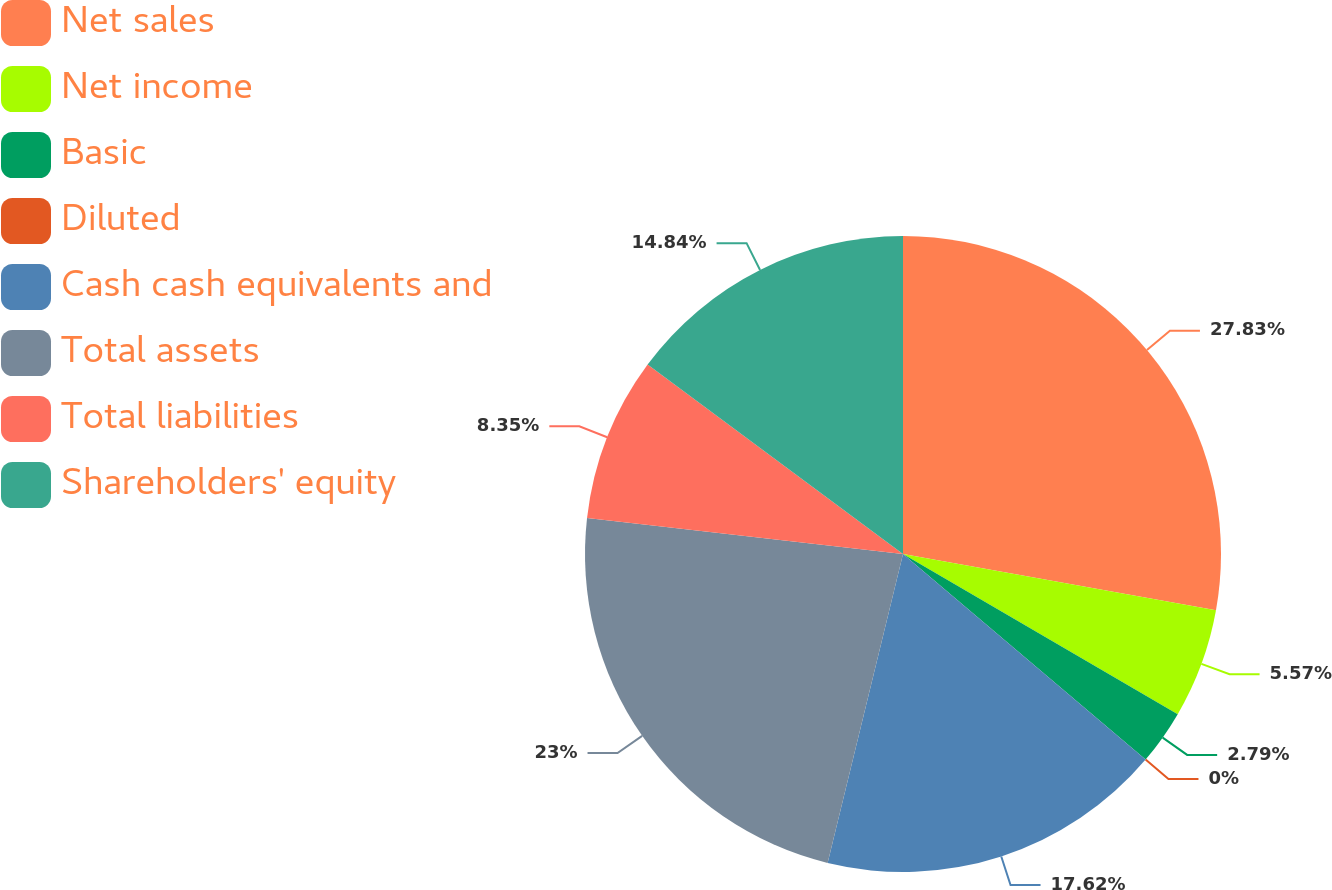Convert chart. <chart><loc_0><loc_0><loc_500><loc_500><pie_chart><fcel>Net sales<fcel>Net income<fcel>Basic<fcel>Diluted<fcel>Cash cash equivalents and<fcel>Total assets<fcel>Total liabilities<fcel>Shareholders' equity<nl><fcel>27.83%<fcel>5.57%<fcel>2.79%<fcel>0.0%<fcel>17.62%<fcel>23.0%<fcel>8.35%<fcel>14.84%<nl></chart> 